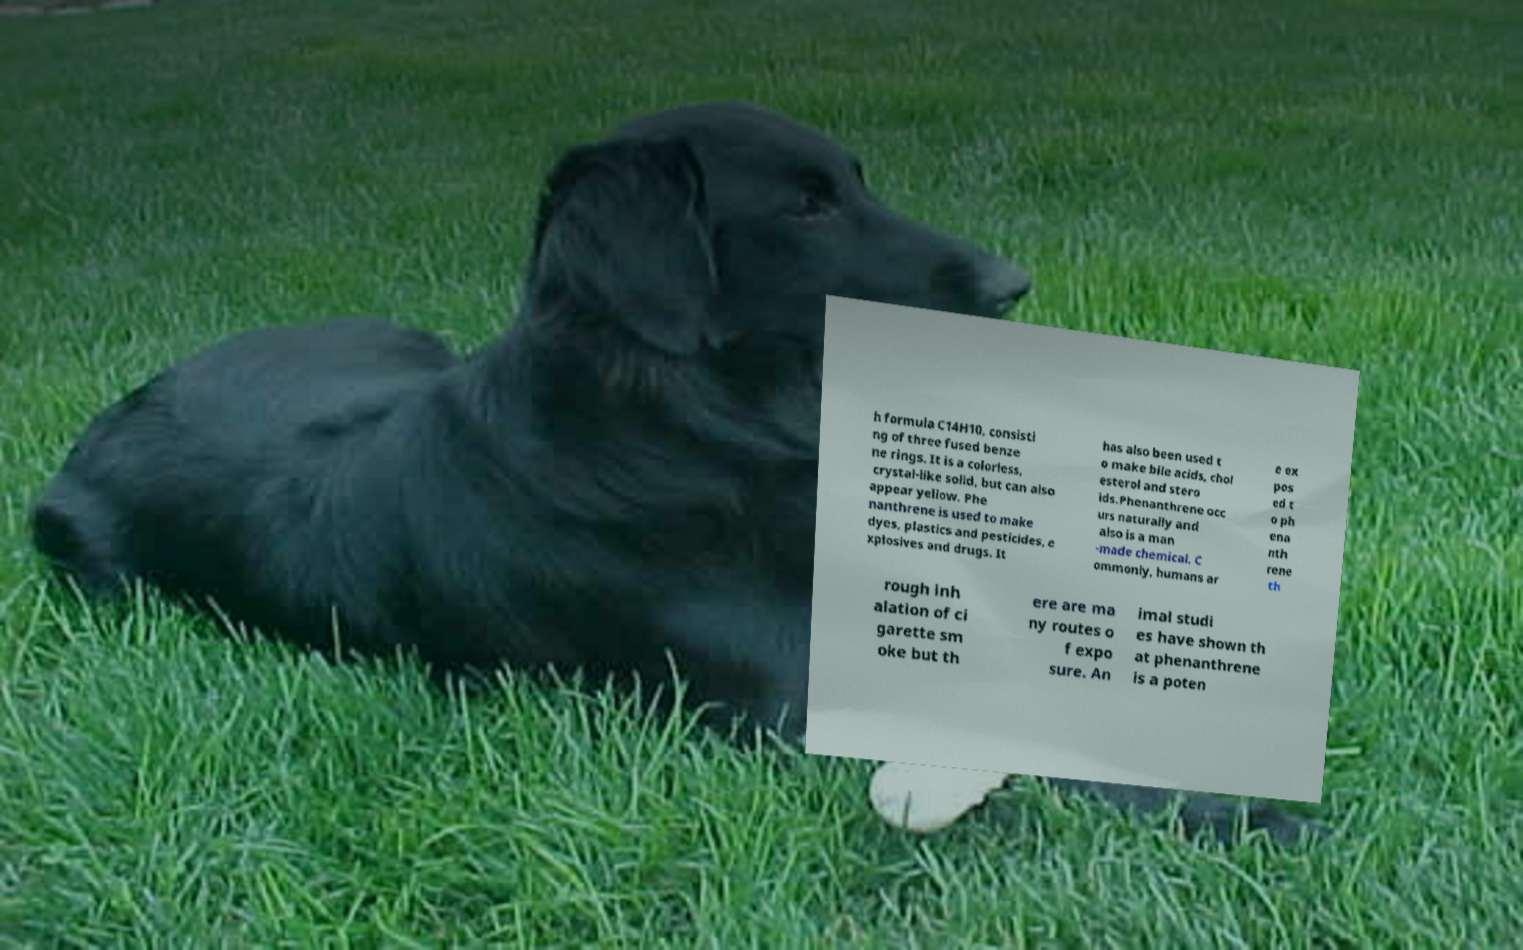For documentation purposes, I need the text within this image transcribed. Could you provide that? h formula C14H10, consisti ng of three fused benze ne rings. It is a colorless, crystal-like solid, but can also appear yellow. Phe nanthrene is used to make dyes, plastics and pesticides, e xplosives and drugs. It has also been used t o make bile acids, chol esterol and stero ids.Phenanthrene occ urs naturally and also is a man -made chemical. C ommonly, humans ar e ex pos ed t o ph ena nth rene th rough inh alation of ci garette sm oke but th ere are ma ny routes o f expo sure. An imal studi es have shown th at phenanthrene is a poten 